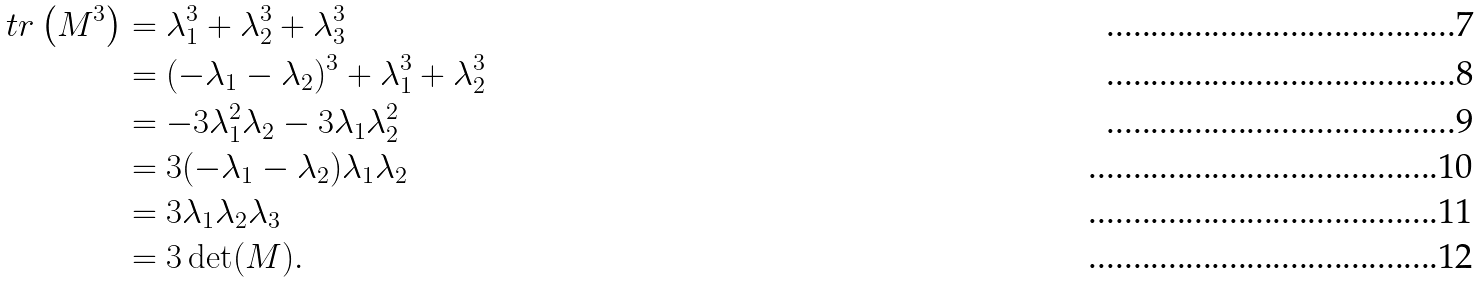<formula> <loc_0><loc_0><loc_500><loc_500>\ t r \left ( M ^ { 3 } \right ) & = \lambda _ { 1 } ^ { 3 } + \lambda _ { 2 } ^ { 3 } + \lambda _ { 3 } ^ { 3 } \\ & = ( - \lambda _ { 1 } - \lambda _ { 2 } ) ^ { 3 } + \lambda _ { 1 } ^ { 3 } + \lambda _ { 2 } ^ { 3 } \\ & = - 3 \lambda _ { 1 } ^ { 2 } \lambda _ { 2 } - 3 \lambda _ { 1 } \lambda _ { 2 } ^ { 2 } \\ & = 3 ( - \lambda _ { 1 } - \lambda _ { 2 } ) \lambda _ { 1 } \lambda _ { 2 } \\ & = 3 \lambda _ { 1 } \lambda _ { 2 } \lambda _ { 3 } \\ & = 3 \det ( M ) .</formula> 